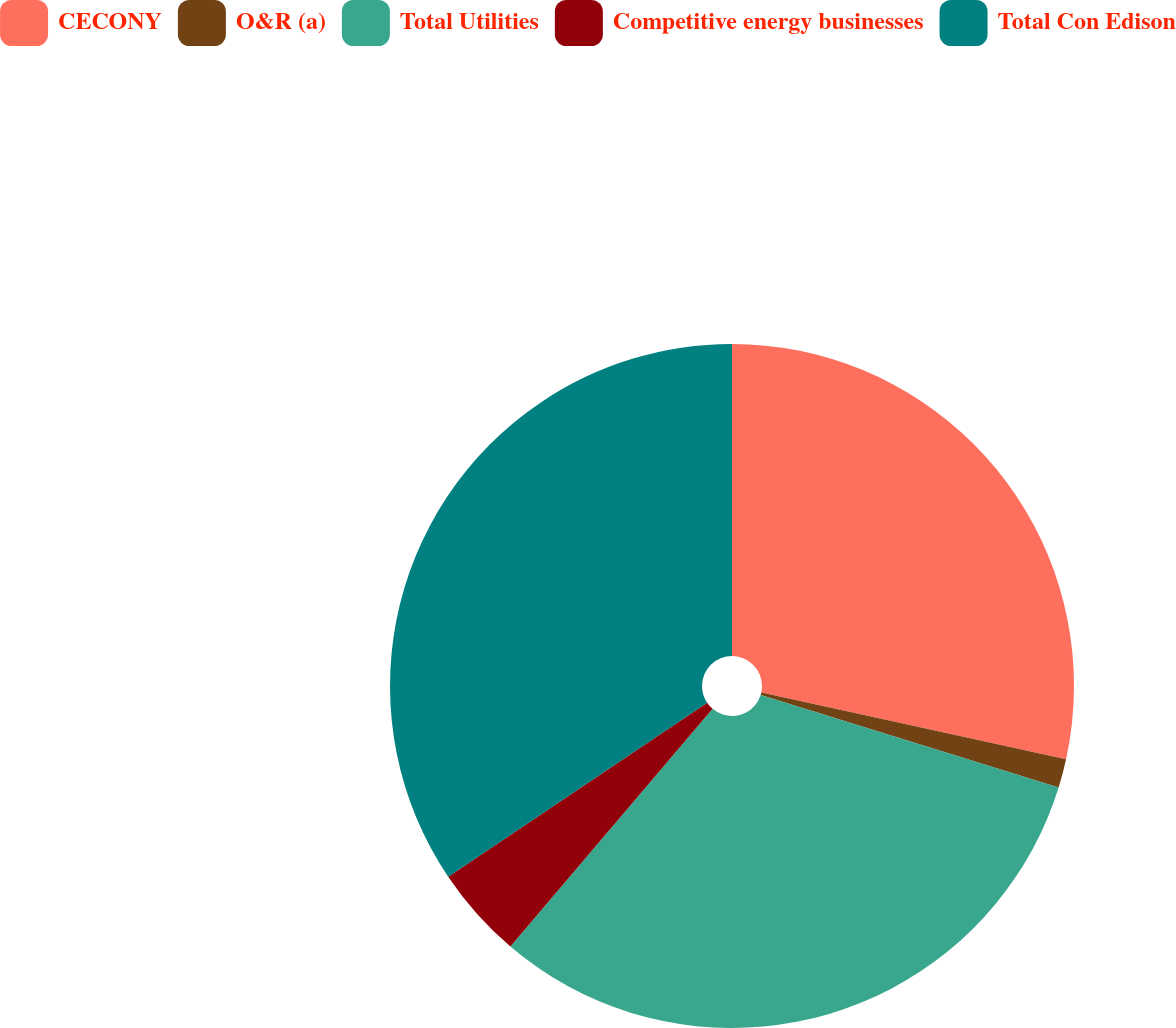Convert chart to OTSL. <chart><loc_0><loc_0><loc_500><loc_500><pie_chart><fcel>CECONY<fcel>O&R (a)<fcel>Total Utilities<fcel>Competitive energy businesses<fcel>Total Con Edison<nl><fcel>28.43%<fcel>1.36%<fcel>31.43%<fcel>4.36%<fcel>34.42%<nl></chart> 